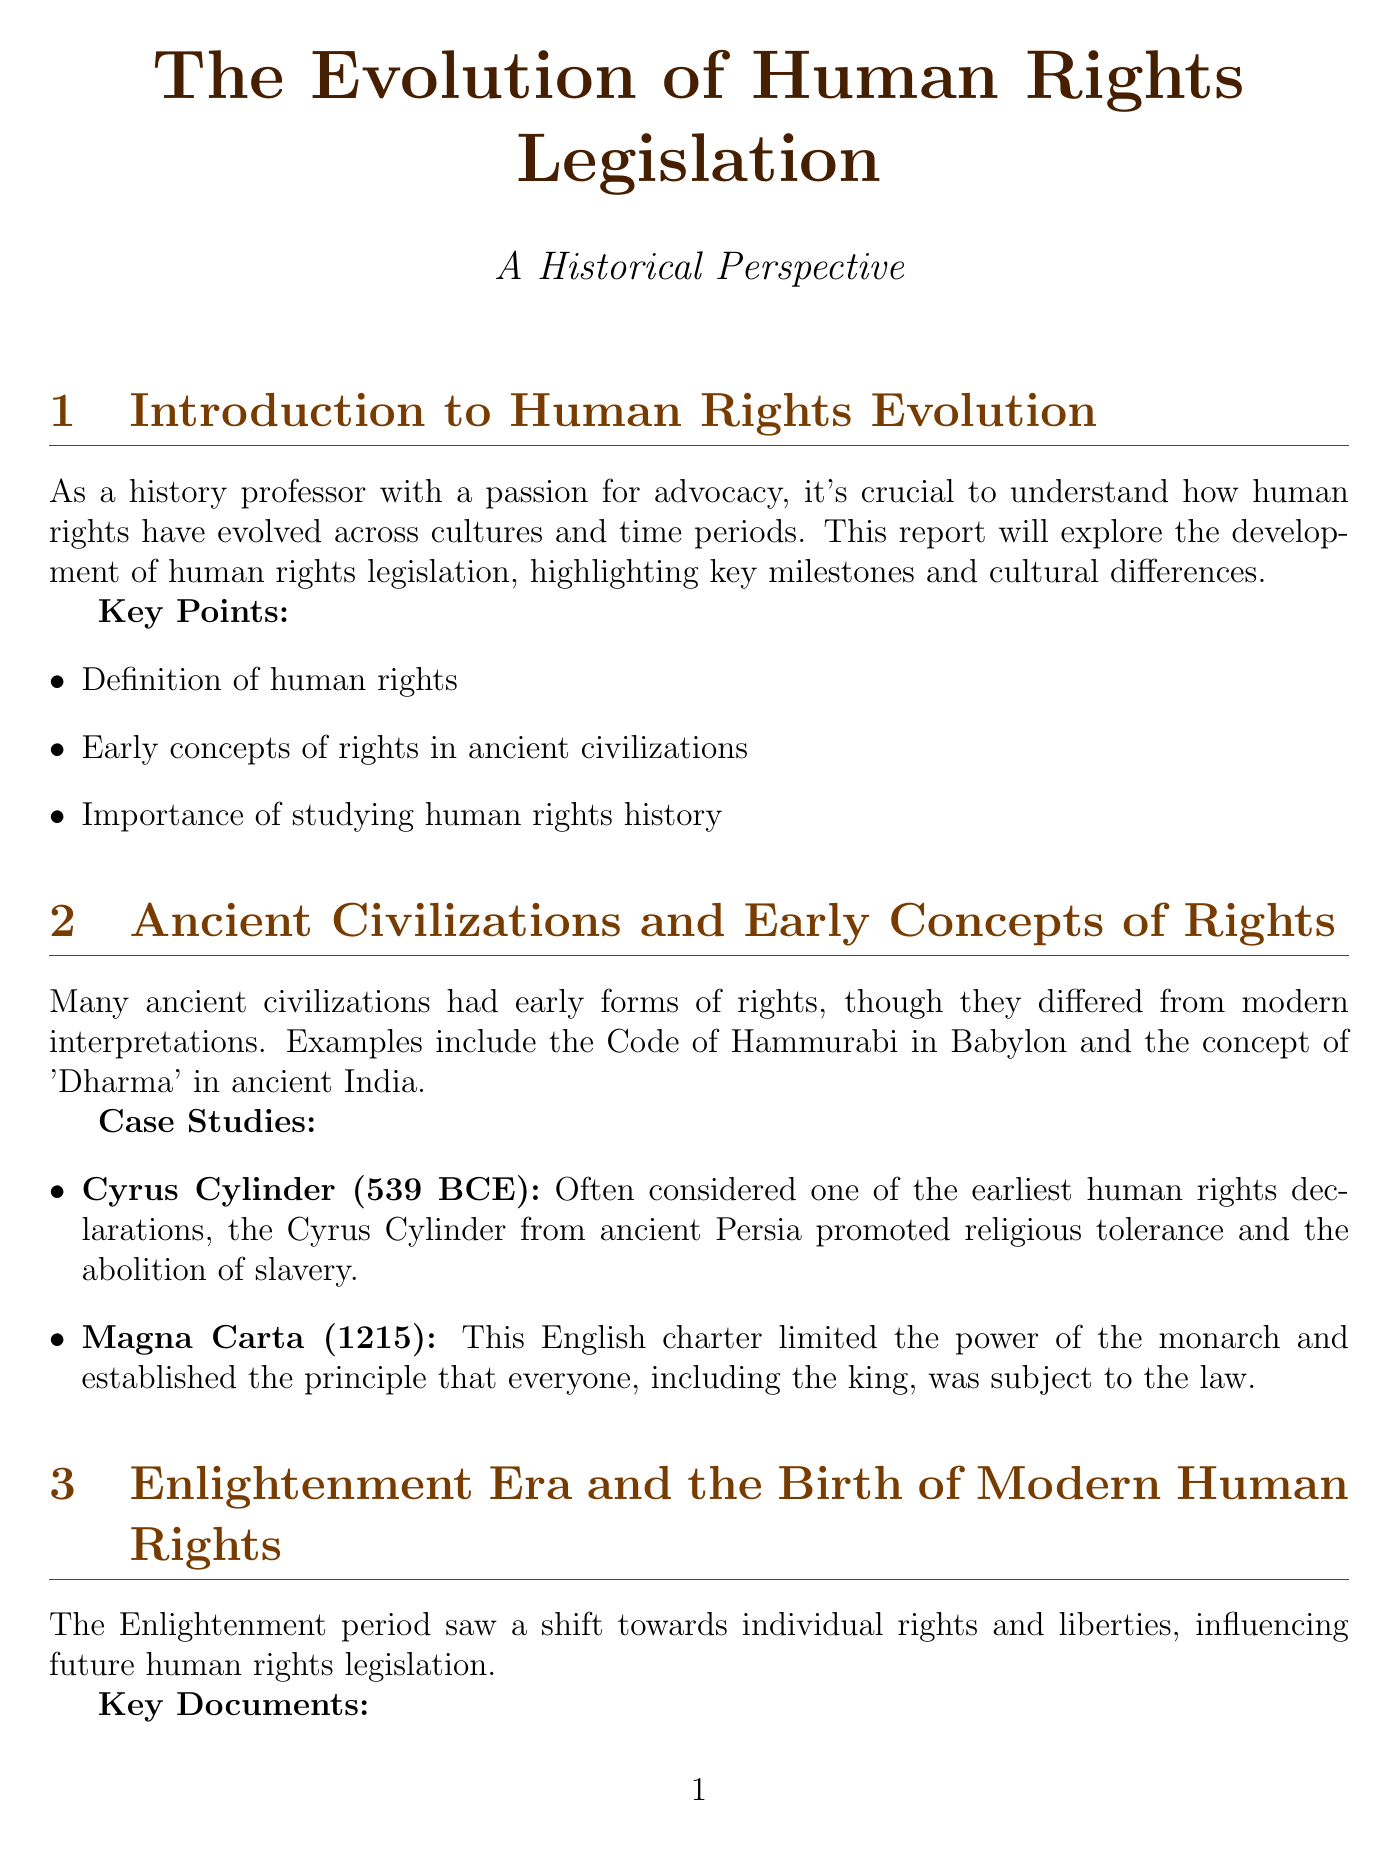What is the title of the report? The title of the report is explicitly mentioned at the beginning of the document as "The Evolution of Human Rights Legislation."
Answer: The Evolution of Human Rights Legislation What year was the Universal Declaration of Human Rights adopted? The document states that the Universal Declaration of Human Rights was adopted in 1948.
Answer: 1948 Which civilization's early rights concept is associated with the Code of Hammurabi? The Code of Hammurabi is associated with ancient Babylon as described in the document.
Answer: Babylon What landmark decision declared racial segregation in public schools unconstitutional? The document mentions the landmark decision "Brown v. Board of Education" which ruled on this issue.
Answer: Brown v. Board of Education What unique aspect does the African Charter on Human and Peoples' Rights include? The unique aspect mentioned is that it includes collective rights and individual duties, as highlighted in the document.
Answer: Collective rights and individual duties What significant event prompted increased international cooperation on human rights issues? The document states that the horrors of World War II led to this increased cooperation.
Answer: World War II What document was created in 1990 related to human rights in the Islamic context? The document notes the "Cairo Declaration on Human Rights in Islam" as being created in 1990.
Answer: Cairo Declaration on Human Rights in Islam What is one contemporary issue regarding human rights mentioned in the report? The report lists "Digital privacy rights" as one of the current issues concerning human rights.
Answer: Digital privacy rights 